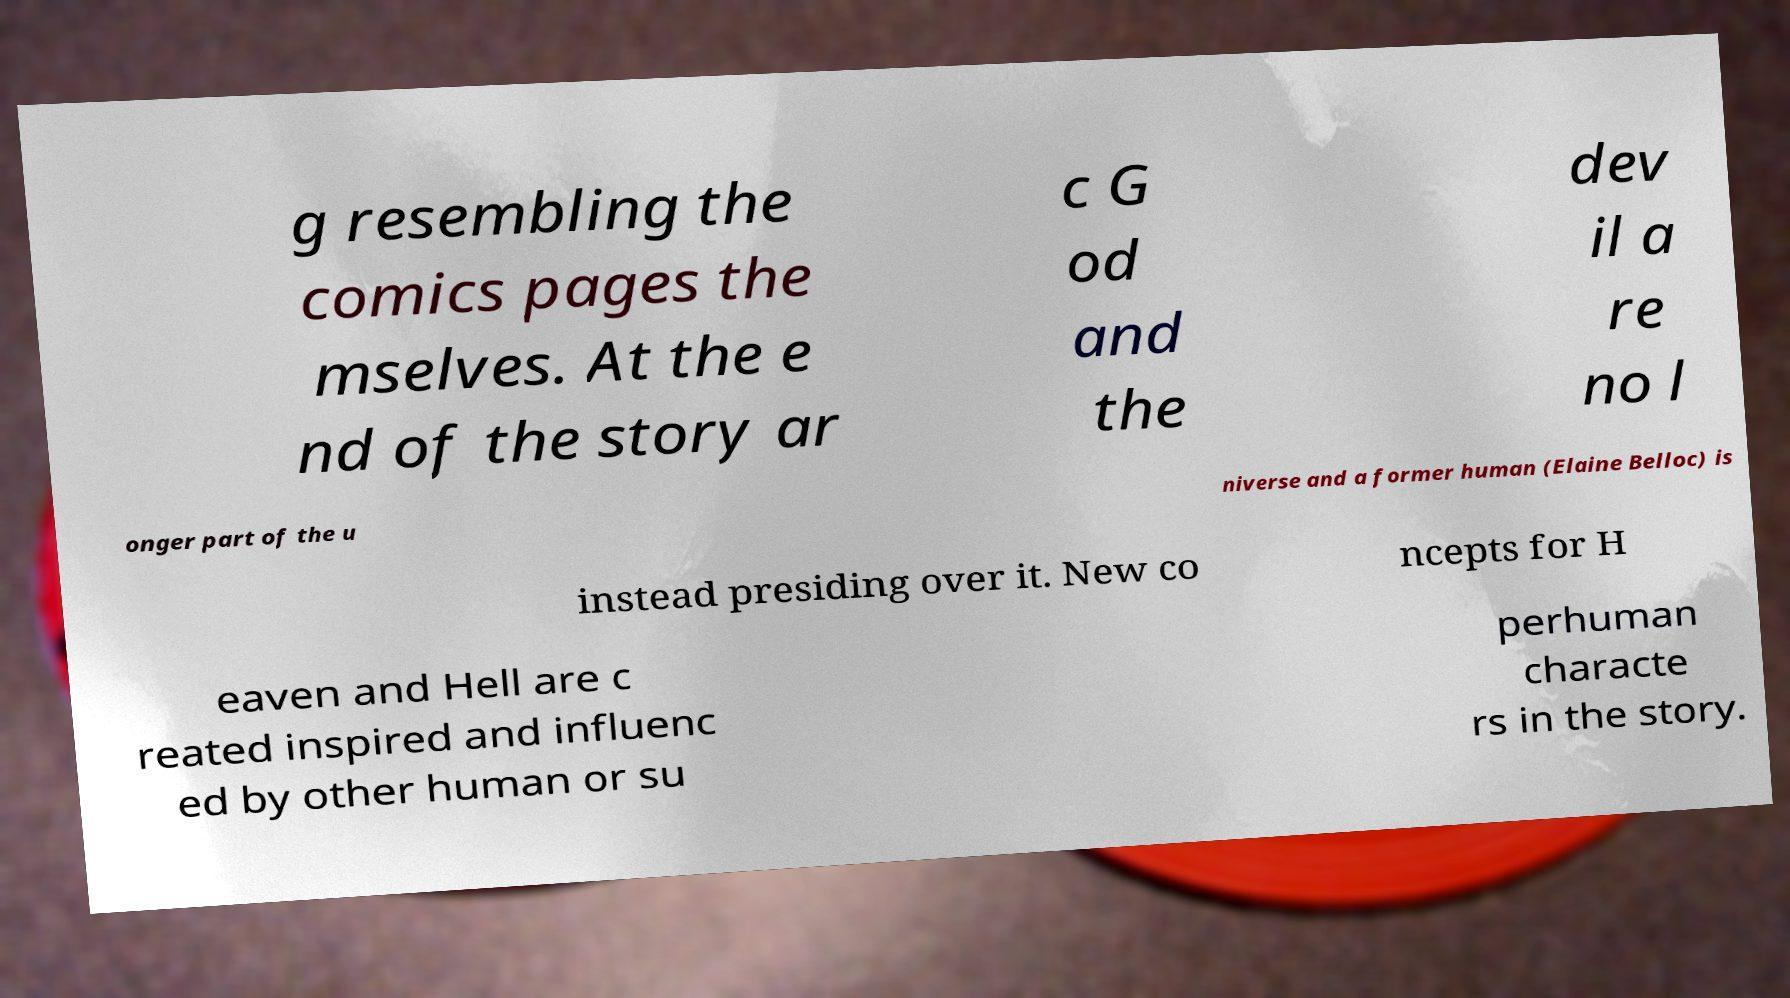I need the written content from this picture converted into text. Can you do that? g resembling the comics pages the mselves. At the e nd of the story ar c G od and the dev il a re no l onger part of the u niverse and a former human (Elaine Belloc) is instead presiding over it. New co ncepts for H eaven and Hell are c reated inspired and influenc ed by other human or su perhuman characte rs in the story. 